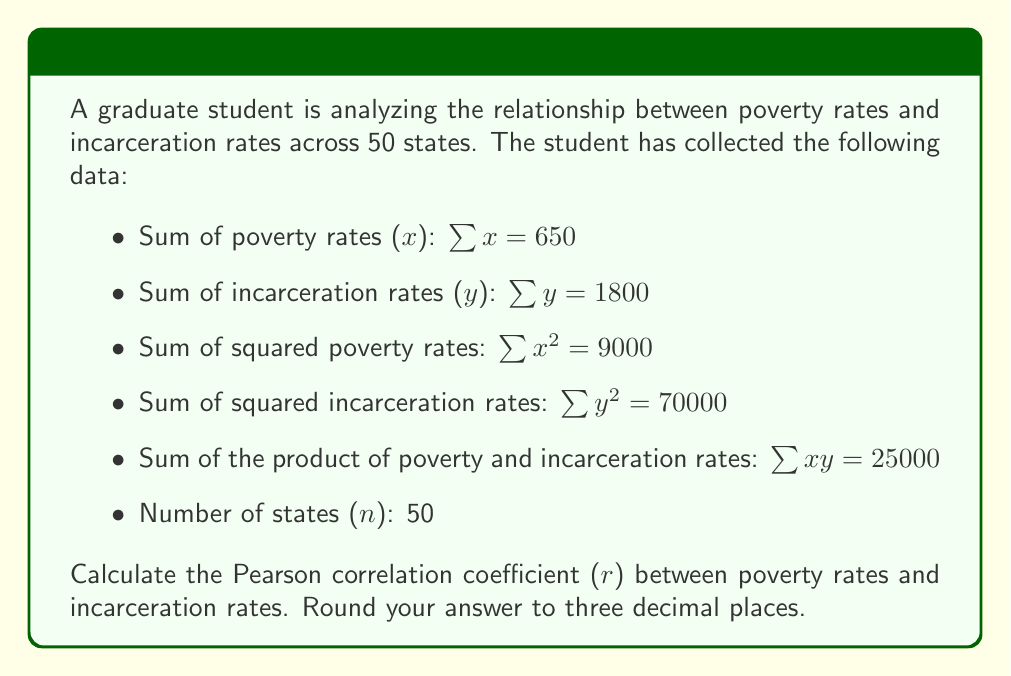Give your solution to this math problem. To calculate the Pearson correlation coefficient (r), we'll use the formula:

$$ r = \frac{n\sum xy - \sum x \sum y}{\sqrt{[n\sum x^2 - (\sum x)^2][n\sum y^2 - (\sum y)^2]}} $$

Let's substitute the given values:

$n = 50$
$\sum x = 650$
$\sum y = 1800$
$\sum x^2 = 9000$
$\sum y^2 = 70000$
$\sum xy = 25000$

Now, let's calculate step by step:

1) Numerator:
   $n\sum xy - \sum x \sum y = (50 \times 25000) - (650 \times 1800) = 1250000 - 1170000 = 80000$

2) Denominator part 1:
   $n\sum x^2 - (\sum x)^2 = (50 \times 9000) - (650)^2 = 450000 - 422500 = 27500$

3) Denominator part 2:
   $n\sum y^2 - (\sum y)^2 = (50 \times 70000) - (1800)^2 = 3500000 - 3240000 = 260000$

4) Complete denominator:
   $\sqrt{27500 \times 260000} = \sqrt{7150000000} = 84556.2$

5) Final calculation:
   $r = \frac{80000}{84556.2} = 0.9461$

Rounding to three decimal places, we get 0.946.
Answer: 0.946 